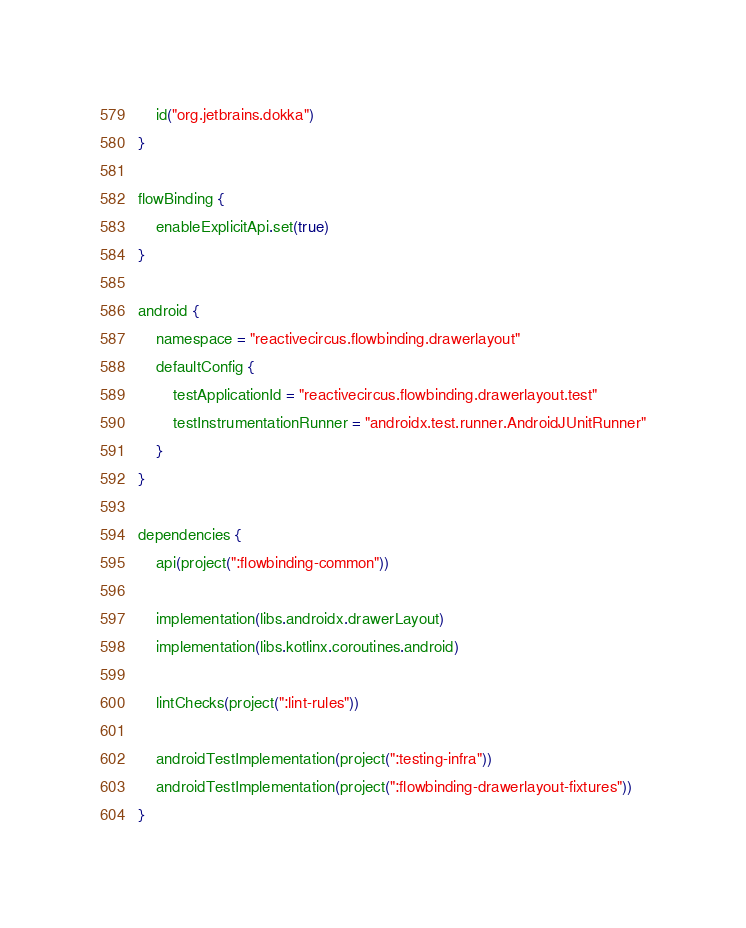<code> <loc_0><loc_0><loc_500><loc_500><_Kotlin_>    id("org.jetbrains.dokka")
}

flowBinding {
    enableExplicitApi.set(true)
}

android {
    namespace = "reactivecircus.flowbinding.drawerlayout"
    defaultConfig {
        testApplicationId = "reactivecircus.flowbinding.drawerlayout.test"
        testInstrumentationRunner = "androidx.test.runner.AndroidJUnitRunner"
    }
}

dependencies {
    api(project(":flowbinding-common"))

    implementation(libs.androidx.drawerLayout)
    implementation(libs.kotlinx.coroutines.android)

    lintChecks(project(":lint-rules"))

    androidTestImplementation(project(":testing-infra"))
    androidTestImplementation(project(":flowbinding-drawerlayout-fixtures"))
}
</code> 